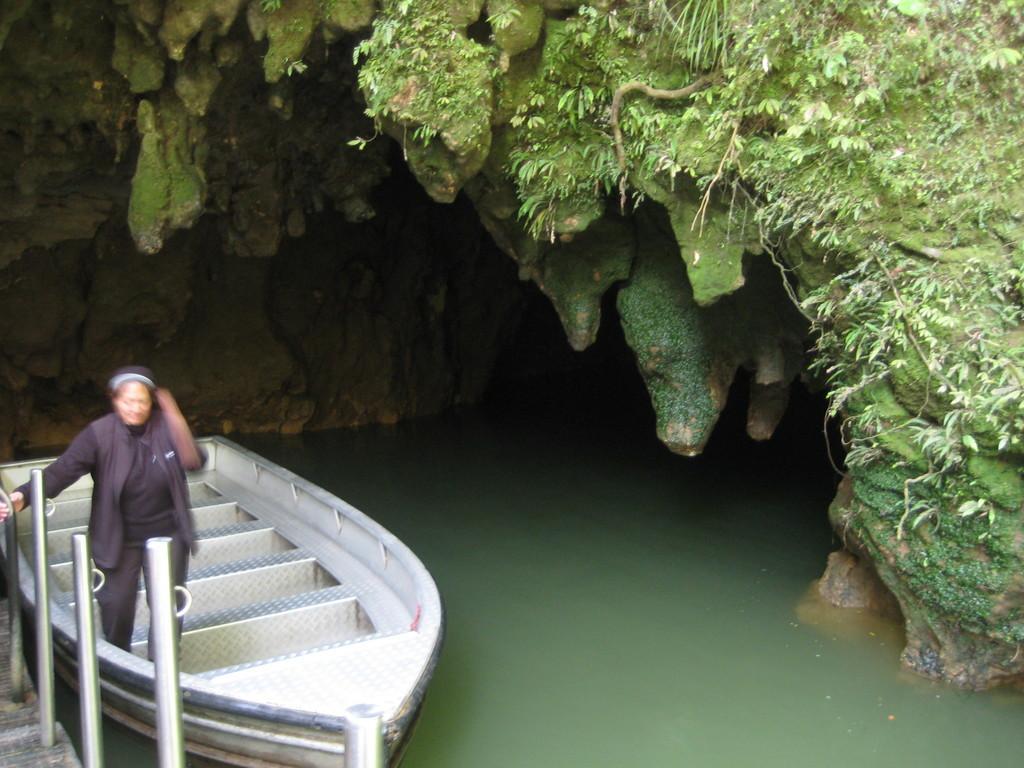How would you summarize this image in a sentence or two? In this image there is the water, there is a boat on the water, there is a woman on the boat, there is a cave, there are plants on the cave, there are metal rods. 